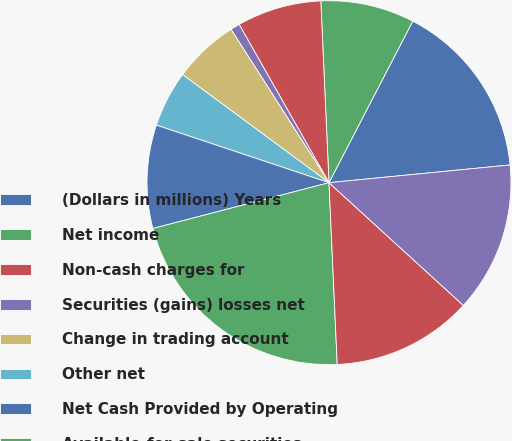<chart> <loc_0><loc_0><loc_500><loc_500><pie_chart><fcel>(Dollars in millions) Years<fcel>Net income<fcel>Non-cash charges for<fcel>Securities (gains) losses net<fcel>Change in trading account<fcel>Other net<fcel>Net Cash Provided by Operating<fcel>Available-for-sale securities<fcel>Held-to-maturity securities<fcel>Lease financing assets<nl><fcel>15.83%<fcel>8.33%<fcel>7.5%<fcel>0.83%<fcel>5.83%<fcel>5.0%<fcel>9.17%<fcel>21.67%<fcel>12.5%<fcel>13.33%<nl></chart> 